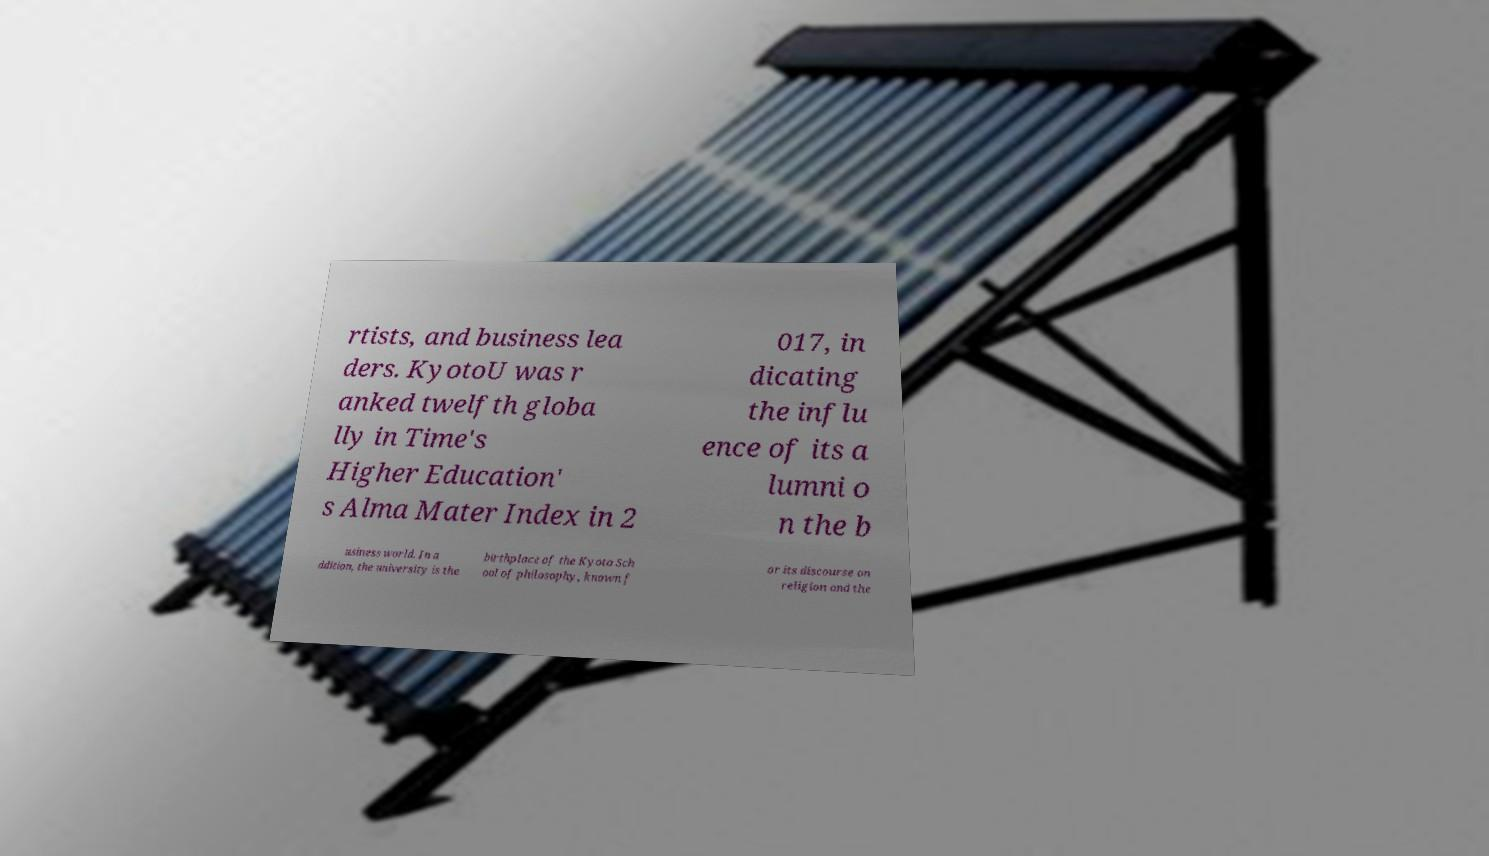There's text embedded in this image that I need extracted. Can you transcribe it verbatim? rtists, and business lea ders. KyotoU was r anked twelfth globa lly in Time's Higher Education' s Alma Mater Index in 2 017, in dicating the influ ence of its a lumni o n the b usiness world. In a ddition, the university is the birthplace of the Kyoto Sch ool of philosophy, known f or its discourse on religion and the 